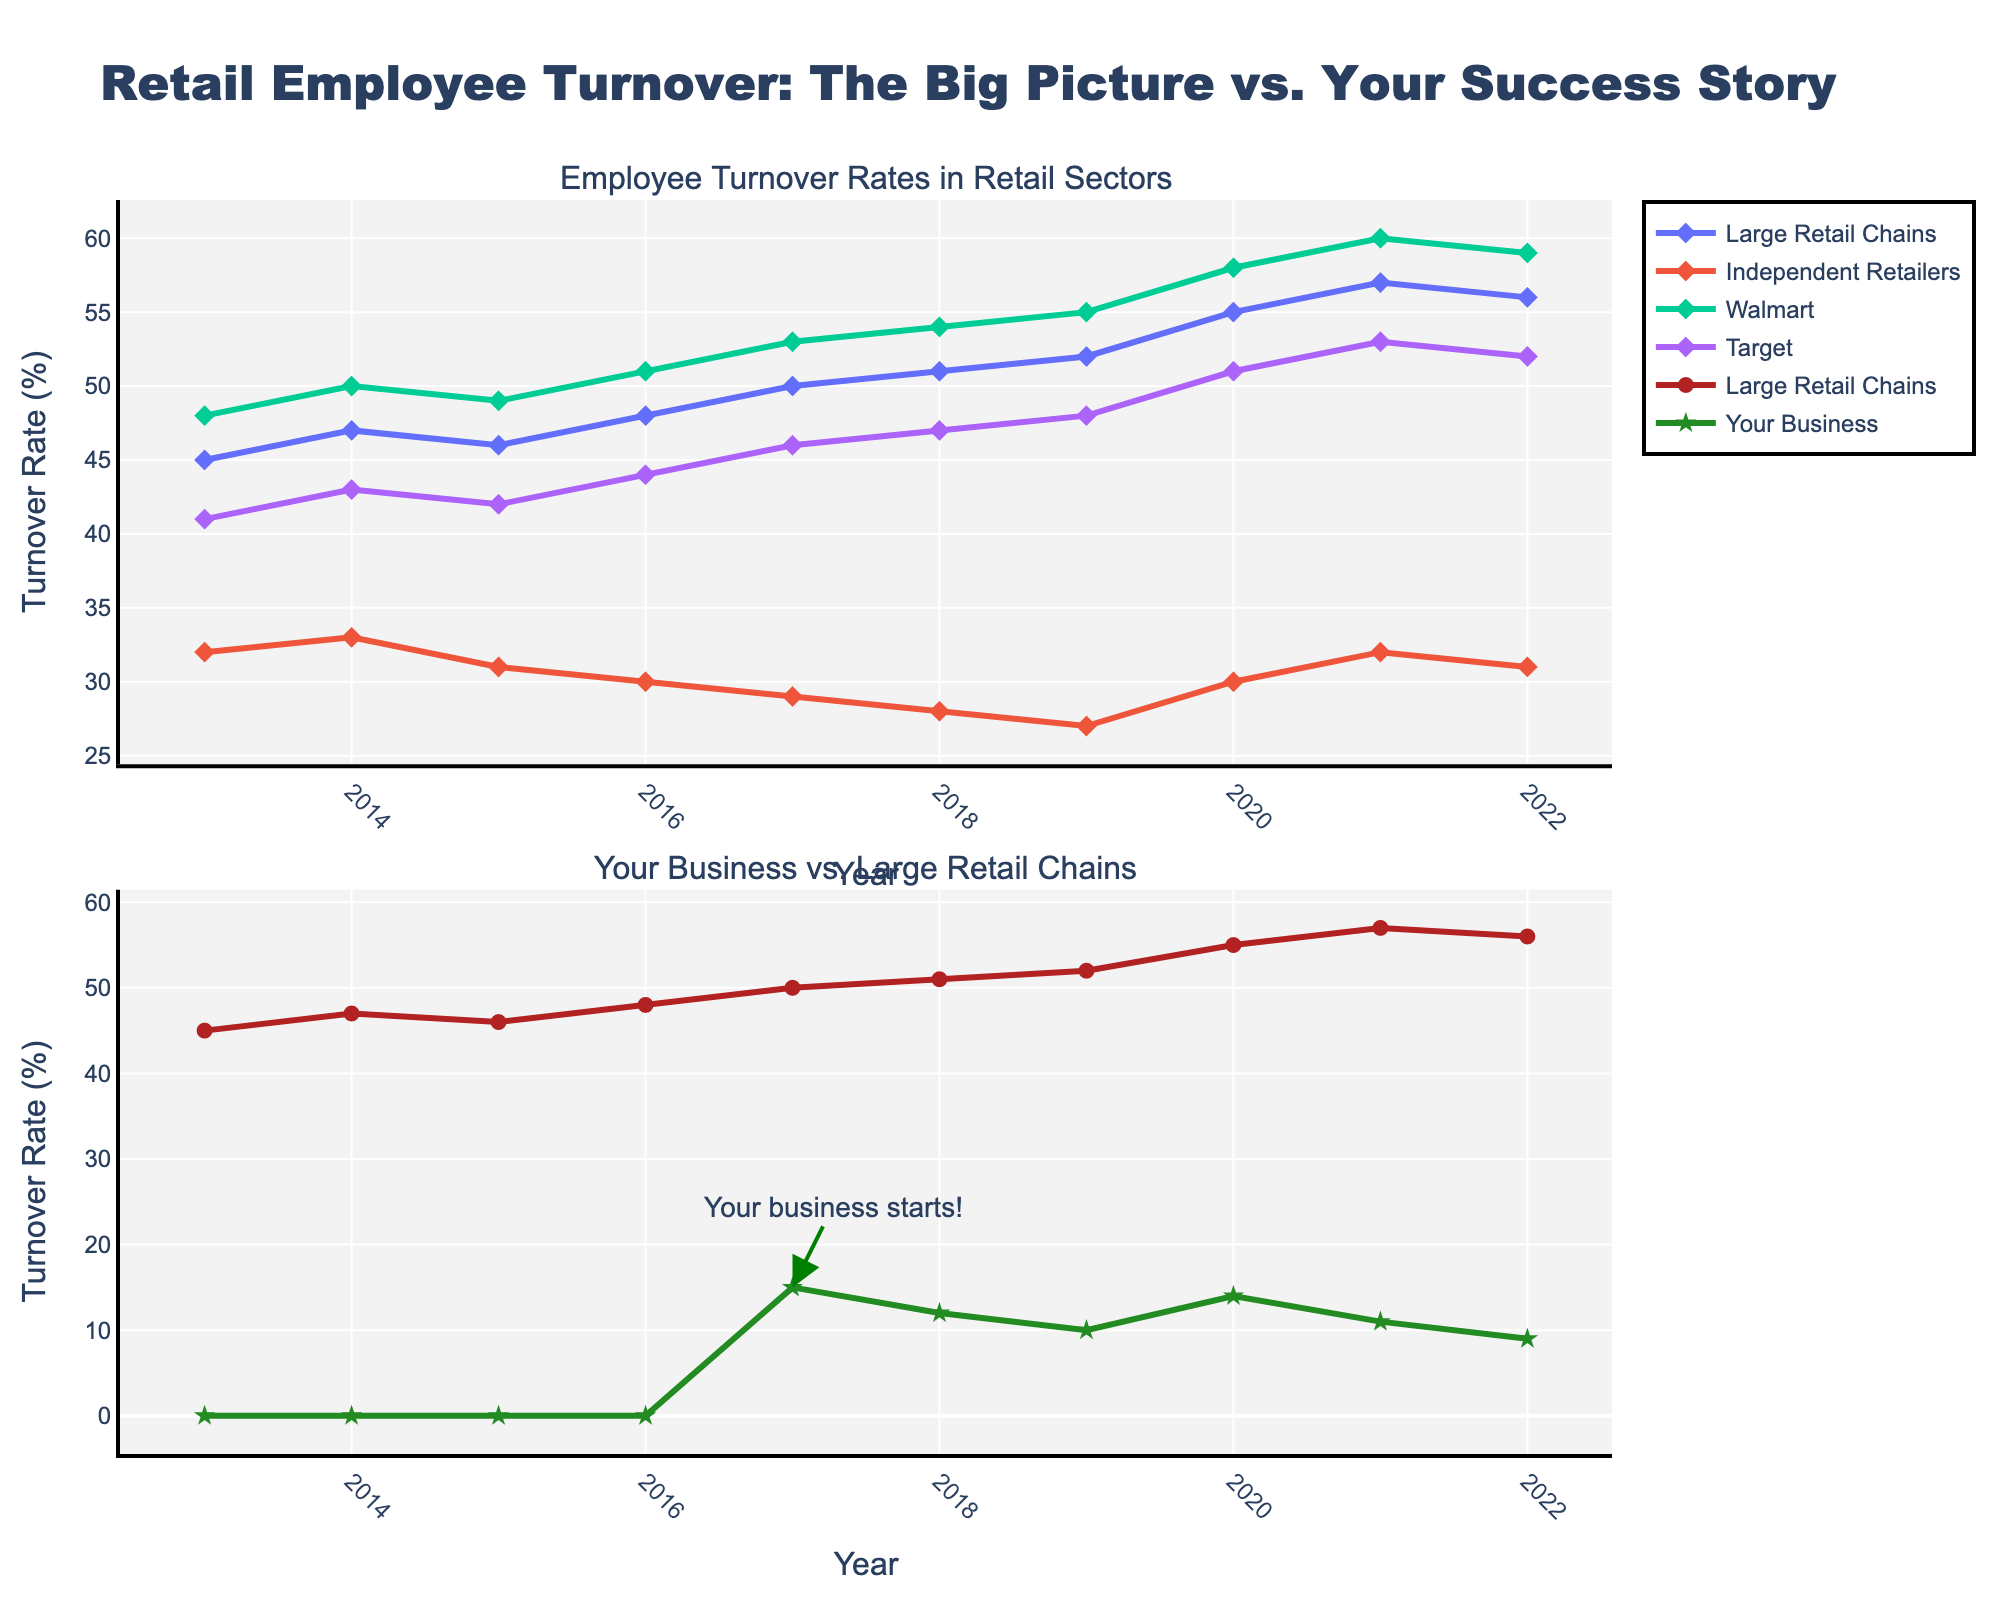What's the title of the figure? The title of the figure is displayed at the top and reads "Retail Employee Turnover: The Big Picture vs. Your Success Story".
Answer: Retail Employee Turnover: The Big Picture vs. Your Success Story What is the turnover rate for Walmart in 2020? Locate the year 2020 on the x-axis and follow it up to the line representing Walmart, which is marked in one of the subplots. The marker at 2020 aligns with a value of 58 on the y-axis.
Answer: 58% Which year did your business have the lowest turnover rate? To find the year with the lowest turnover rate for your business, observe the green star markers in one of the subplots and note the year that aligns with the lowest marker on the y-axis, which is 2022.
Answer: 2022 In 2018, how did the turnover rate for Large Retail Chains compare to Independent Retailers? First, find the year 2018 on the x-axis, then compare the markers for Large Retail Chains (red line) and Independent Retailers (orange line). Large Retail Chains is at 51 and Independent Retailers is at 28, so Large Retail Chains had a higher turnover rate.
Answer: Larger What was the turnover rate difference between Large Retail Chains and Your Business in 2022? Locate the year 2022 on the x-axis and find the corresponding markers for Large Retail Chains and Your Business in the subplot comparing them. Large Retail Chains is at 56 and Your Business is at 9. The difference is 56-9 = 47.
Answer: 47% When did Large Retail Chains experience the highest turnover rate? Examine the line representing Large Retail Chains and identify the highest point on the y-axis. This point occurs in 2021.
Answer: 2021 What trend can be observed in the turnover rates for Large Retail Chains from 2013 to 2022? By observing the line plot for Large Retail Chains across the years, a consistent increasing trend in turnover rates can be noted, from 45 in 2013 to 56 in 2022.
Answer: Increasing How did the employee turnover rate of Your Business change from 2017 to 2022? Locate the line for Your Business starting from when it appears in 2017 to 2022. The markers show a decrease from 15 in 2017 to 9 in 2022.
Answer: Decreased Compare the average turnover rate of Walmart and Target over the decade. Calculate the average for both Walmart and Target by summing their turnover rates from 2013 to 2022 and dividing by the number of years (10). Walmart: (48+50+49+51+53+54+55+58+60+59)/10 = 53.7 and Target: (41+43+42+44+46+47+48+51+53+52)/10 = 46.7.
Answer: Walmart: 53.7%, Target: 46.7% What significant event is highlighted in the annotation, and in which year does it occur? The annotation on the plot points to the year 2017 and states "Your business starts!", indicating the start year of your business.
Answer: Your business starts!, 2017 